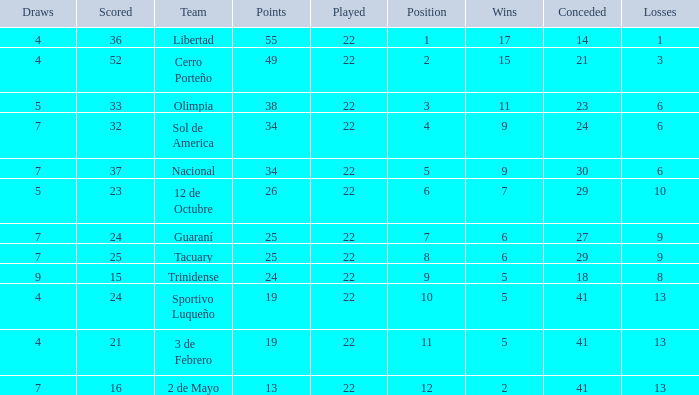What is the number of draws for the team with more than 8 losses and 13 points? 7.0. 